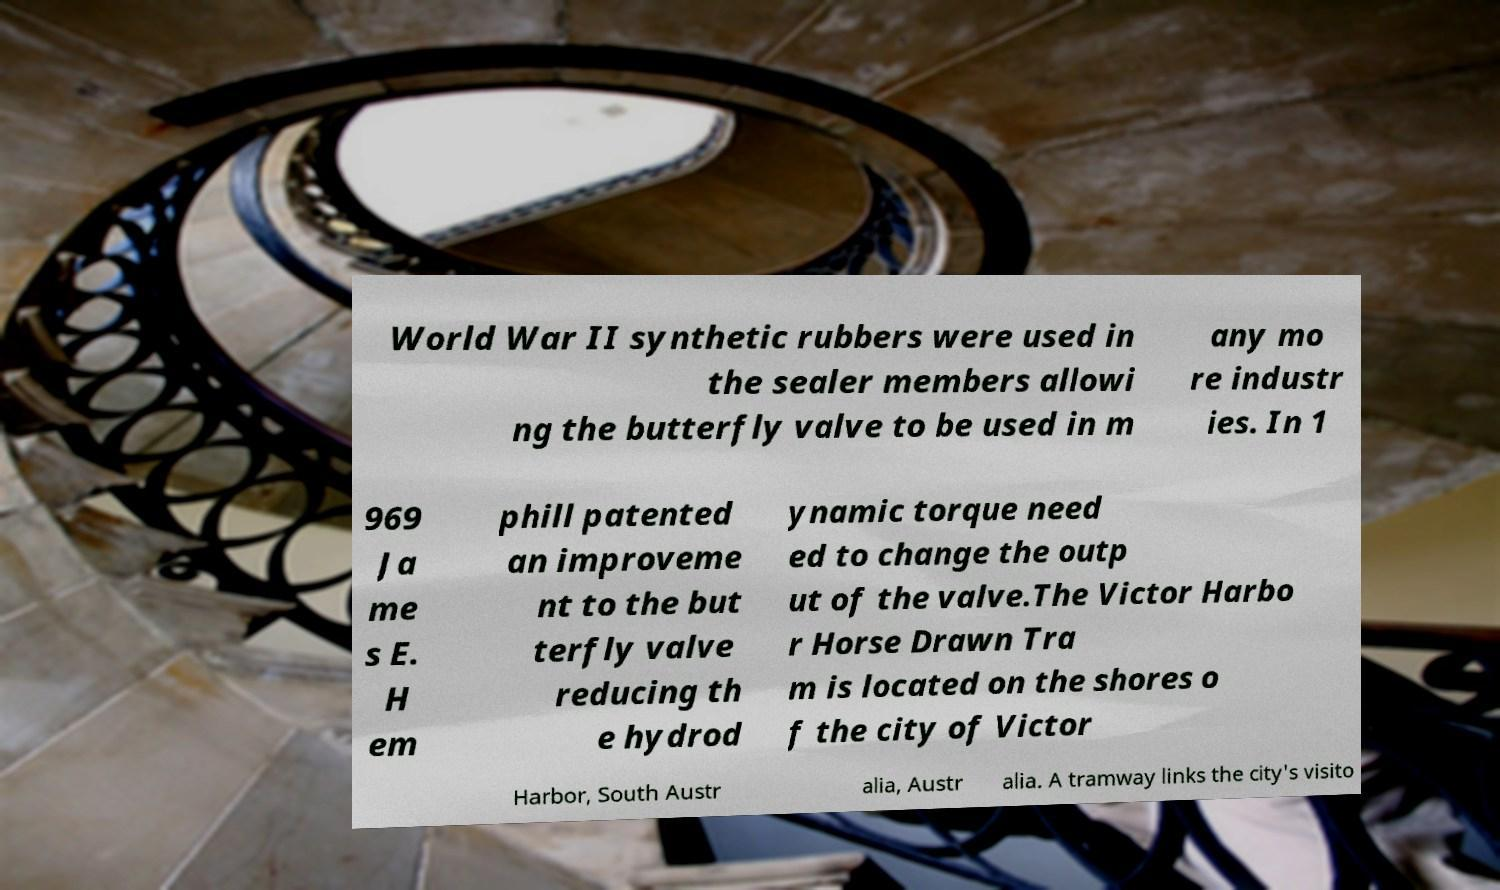What messages or text are displayed in this image? I need them in a readable, typed format. World War II synthetic rubbers were used in the sealer members allowi ng the butterfly valve to be used in m any mo re industr ies. In 1 969 Ja me s E. H em phill patented an improveme nt to the but terfly valve reducing th e hydrod ynamic torque need ed to change the outp ut of the valve.The Victor Harbo r Horse Drawn Tra m is located on the shores o f the city of Victor Harbor, South Austr alia, Austr alia. A tramway links the city's visito 